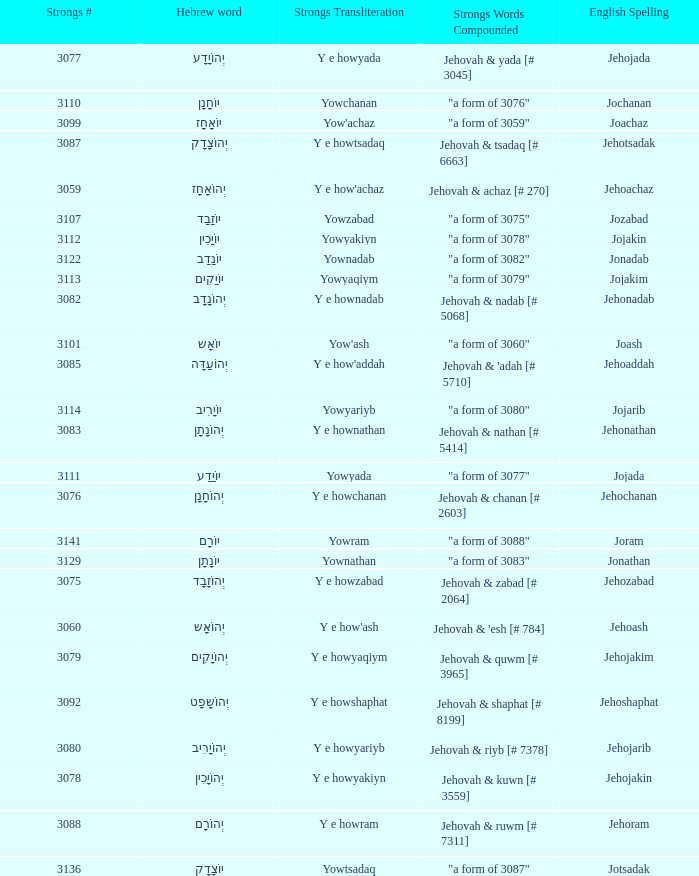How many strongs transliteration of the english spelling of the work jehojakin? 1.0. 